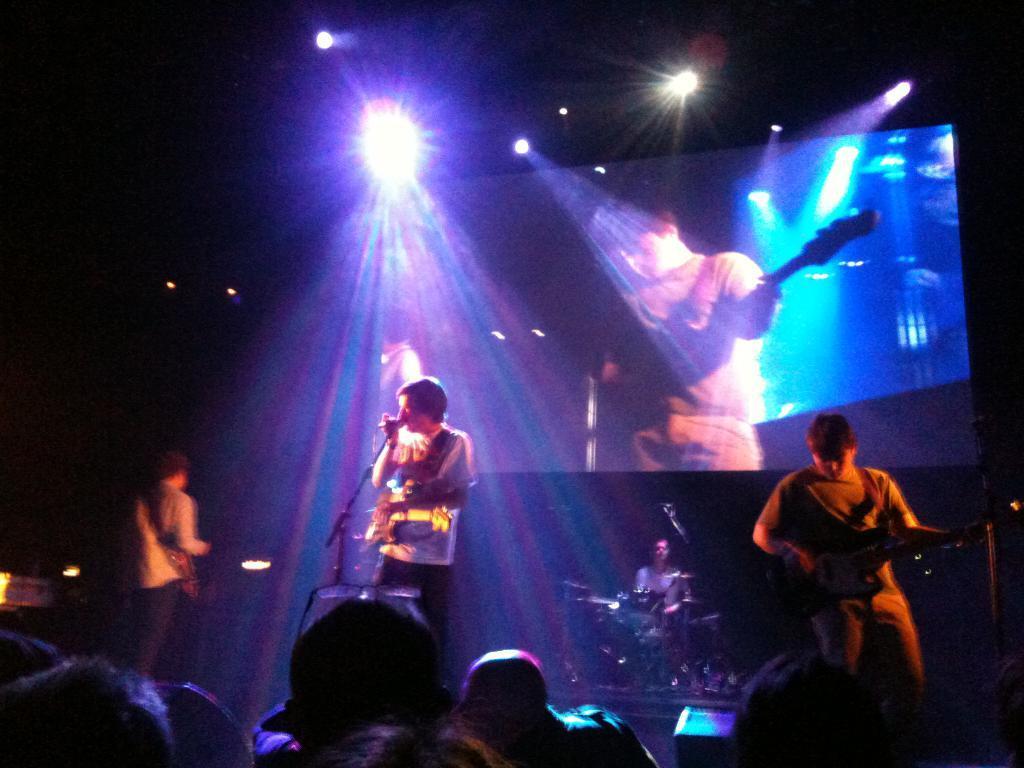How would you summarize this image in a sentence or two? In this picture we can see man holding guitar in his hand and singing on the mic and some persons also playing musical instruments such as drums and in front of them crowd is listening to them and in the background we can see screen, light. 